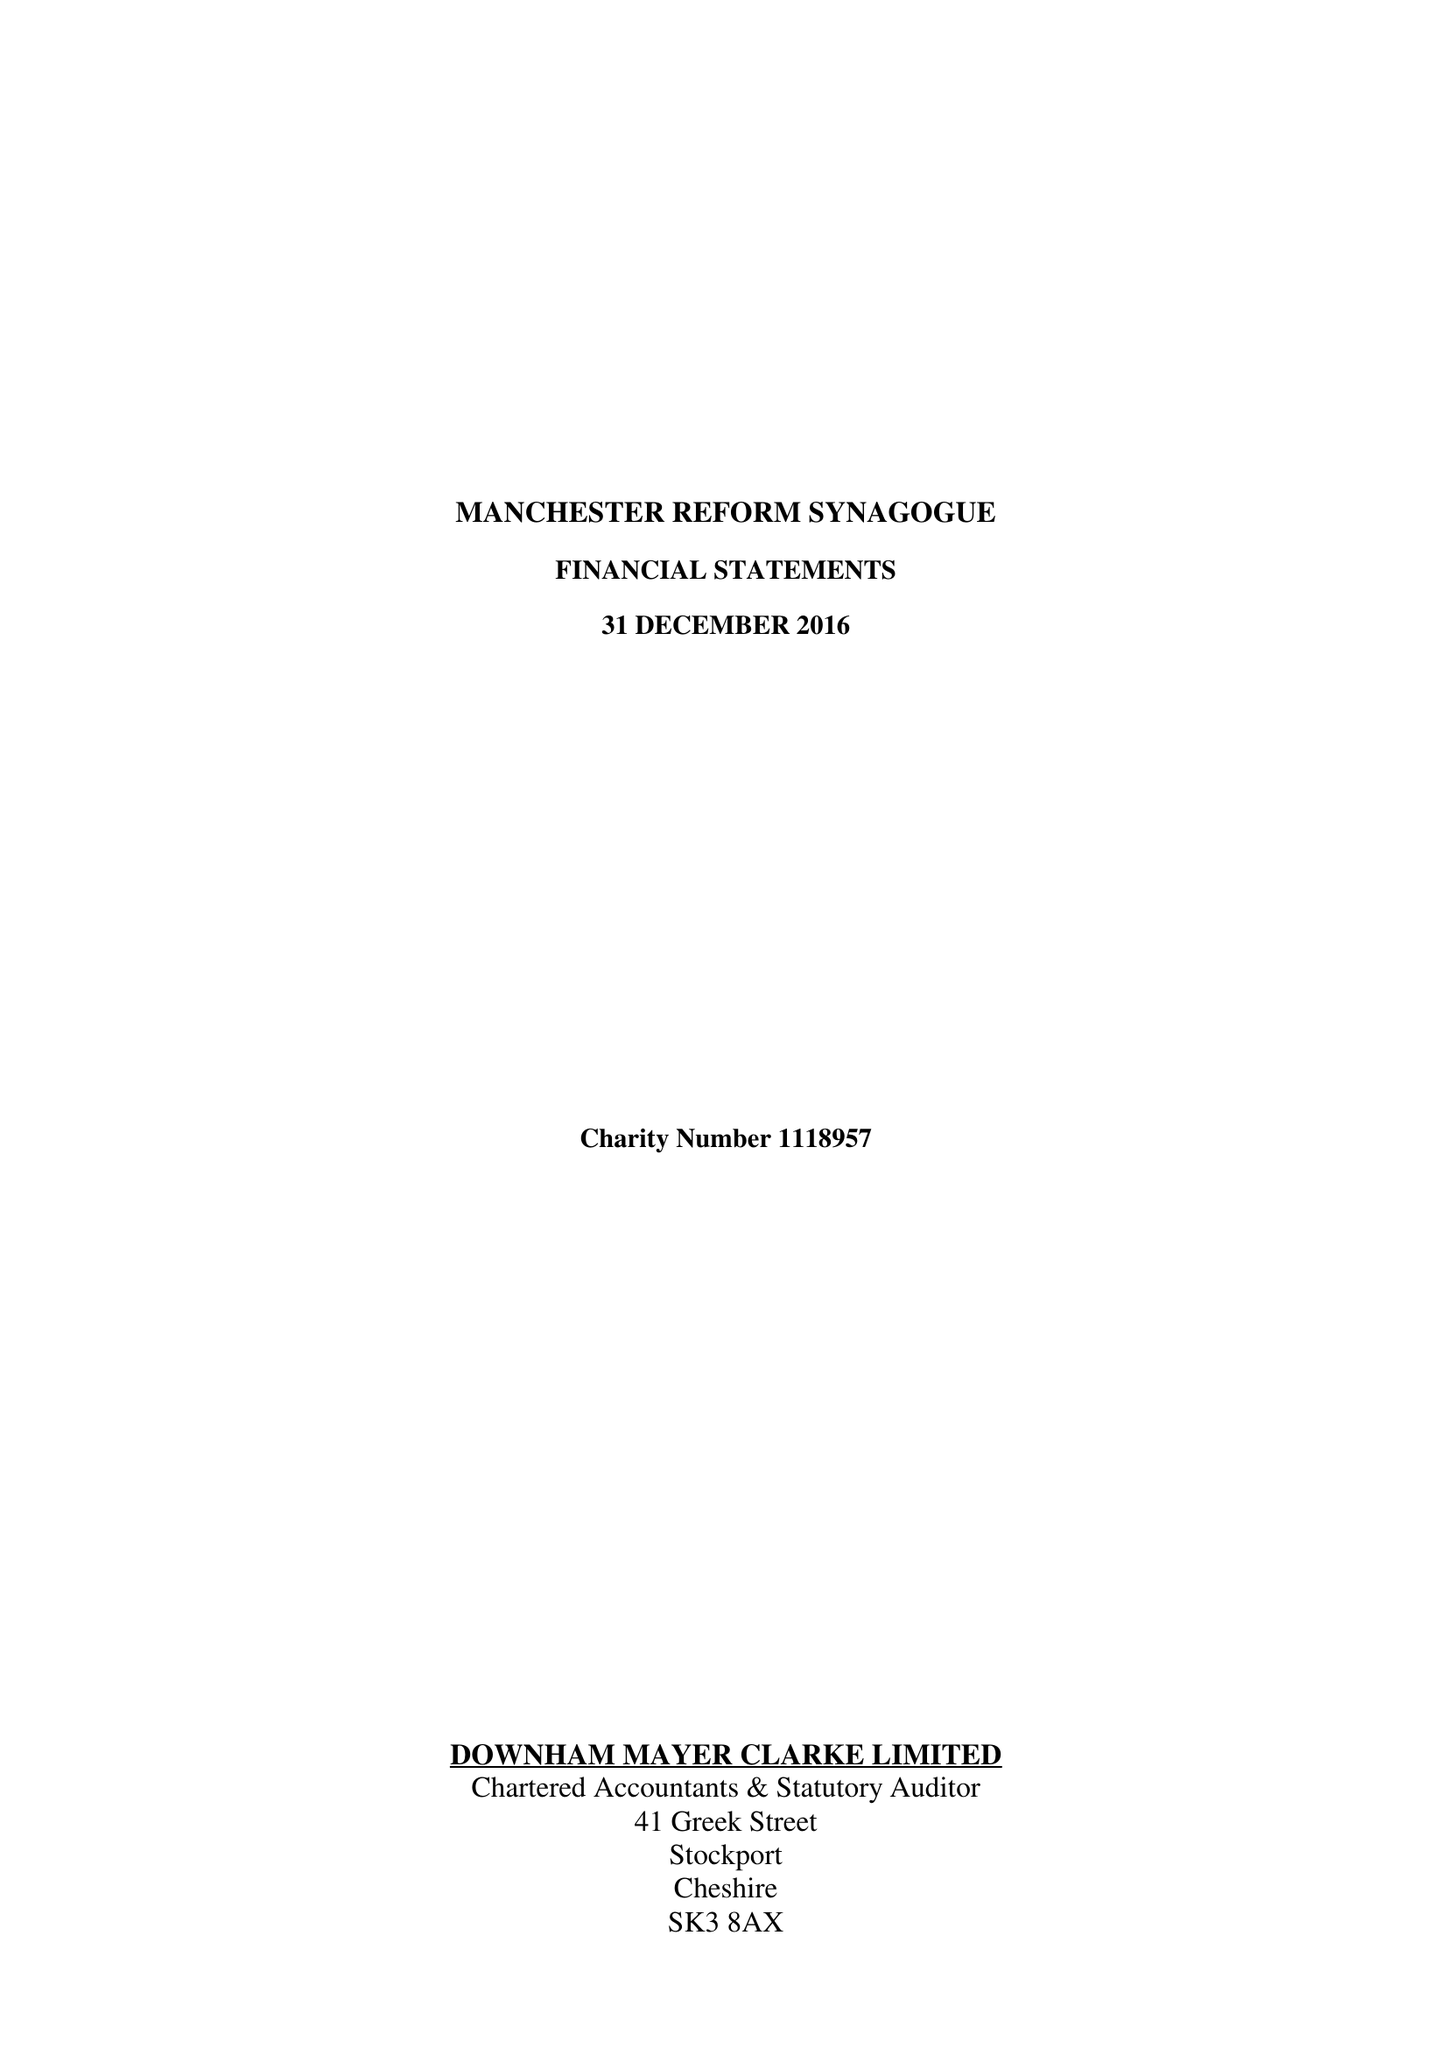What is the value for the address__postcode?
Answer the question using a single word or phrase. M2 5NH 